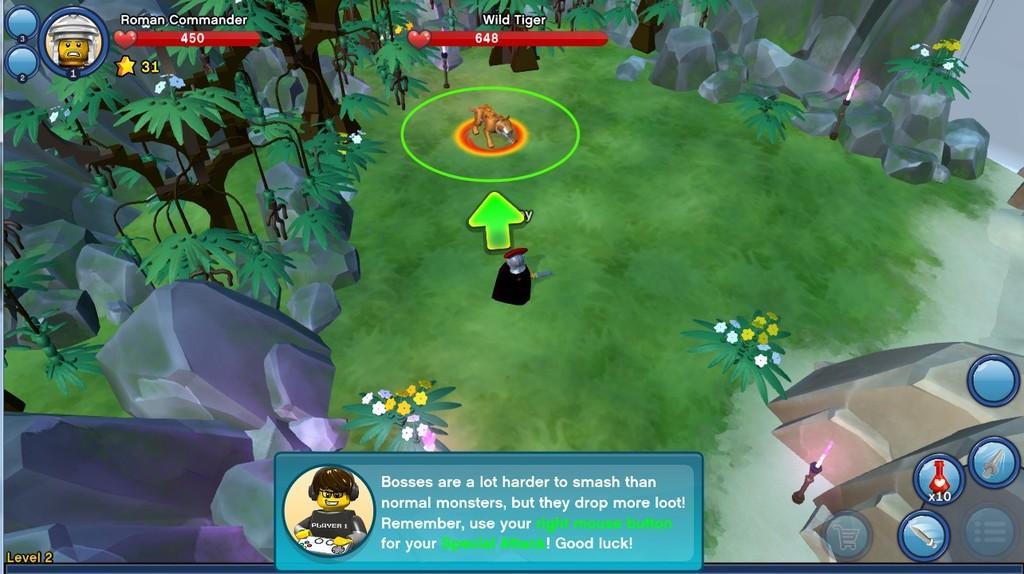Could you give a brief overview of what you see in this image? In this image I can see the digital art in which I can see some grass on the ground, few plants with yellow and white colored flowers, a person standing, an animal, few trees and few rocks on the ground. I can see the white colored door to the top right of the image. 